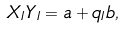<formula> <loc_0><loc_0><loc_500><loc_500>X _ { I } Y _ { I } = a + q _ { I } b ,</formula> 